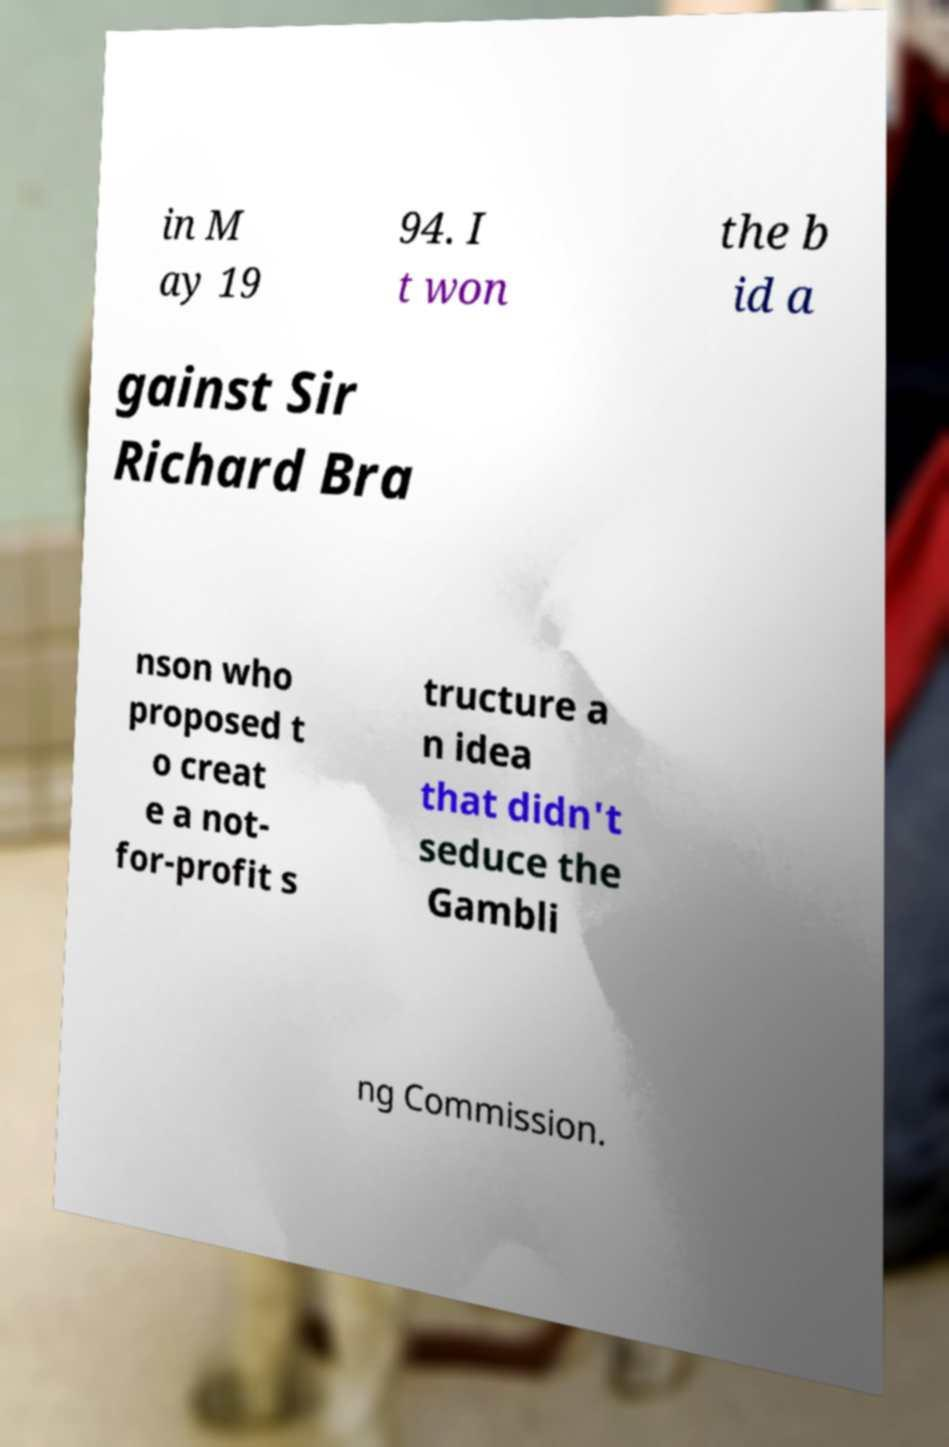What messages or text are displayed in this image? I need them in a readable, typed format. in M ay 19 94. I t won the b id a gainst Sir Richard Bra nson who proposed t o creat e a not- for-profit s tructure a n idea that didn't seduce the Gambli ng Commission. 